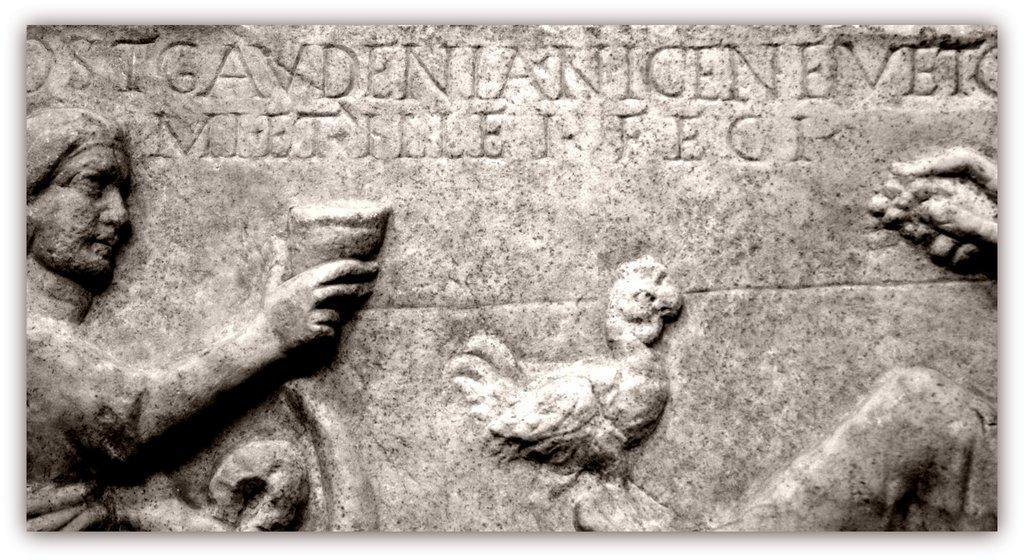Can you describe this image briefly? This image consists of a memorial stone on which there are is a sculpture chiseled and a bird. 